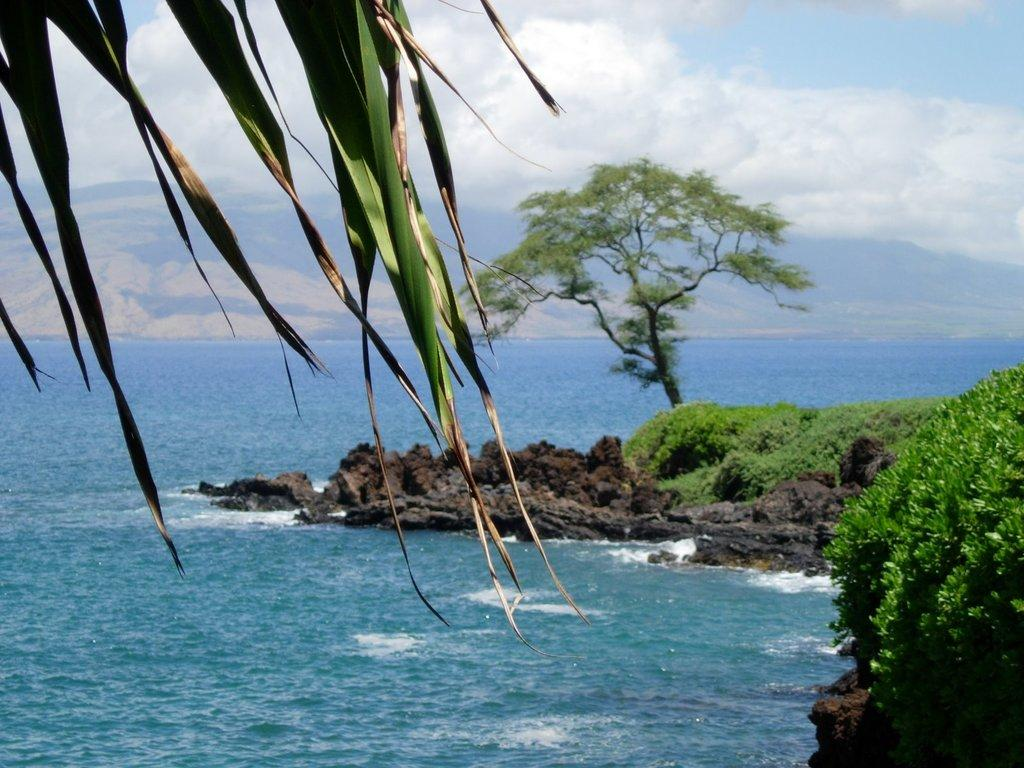What type of plant can be seen in the image? There is a tree in the image. What type of vegetation is present on the ground in the image? There is grass in the image. What is covering the tree and grass in the image? Leaves are present in the image. What can be seen in the image besides the tree and grass? Water and rocks are visible in the image. What is the condition of the sky in the image? The sky is cloudy in the image. What type of peace symbol can be seen in the image? There is no peace symbol present in the image. How many people are in the group depicted in the image? There is no group of people present in the image. 